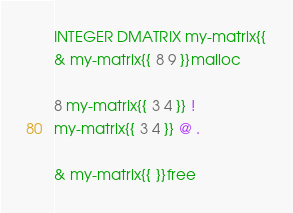<code> <loc_0><loc_0><loc_500><loc_500><_Forth_>INTEGER DMATRIX my-matrix{{
& my-matrix{{ 8 9 }}malloc

8 my-matrix{{ 3 4 }} !
my-matrix{{ 3 4 }} @ .

& my-matrix{{ }}free
</code> 